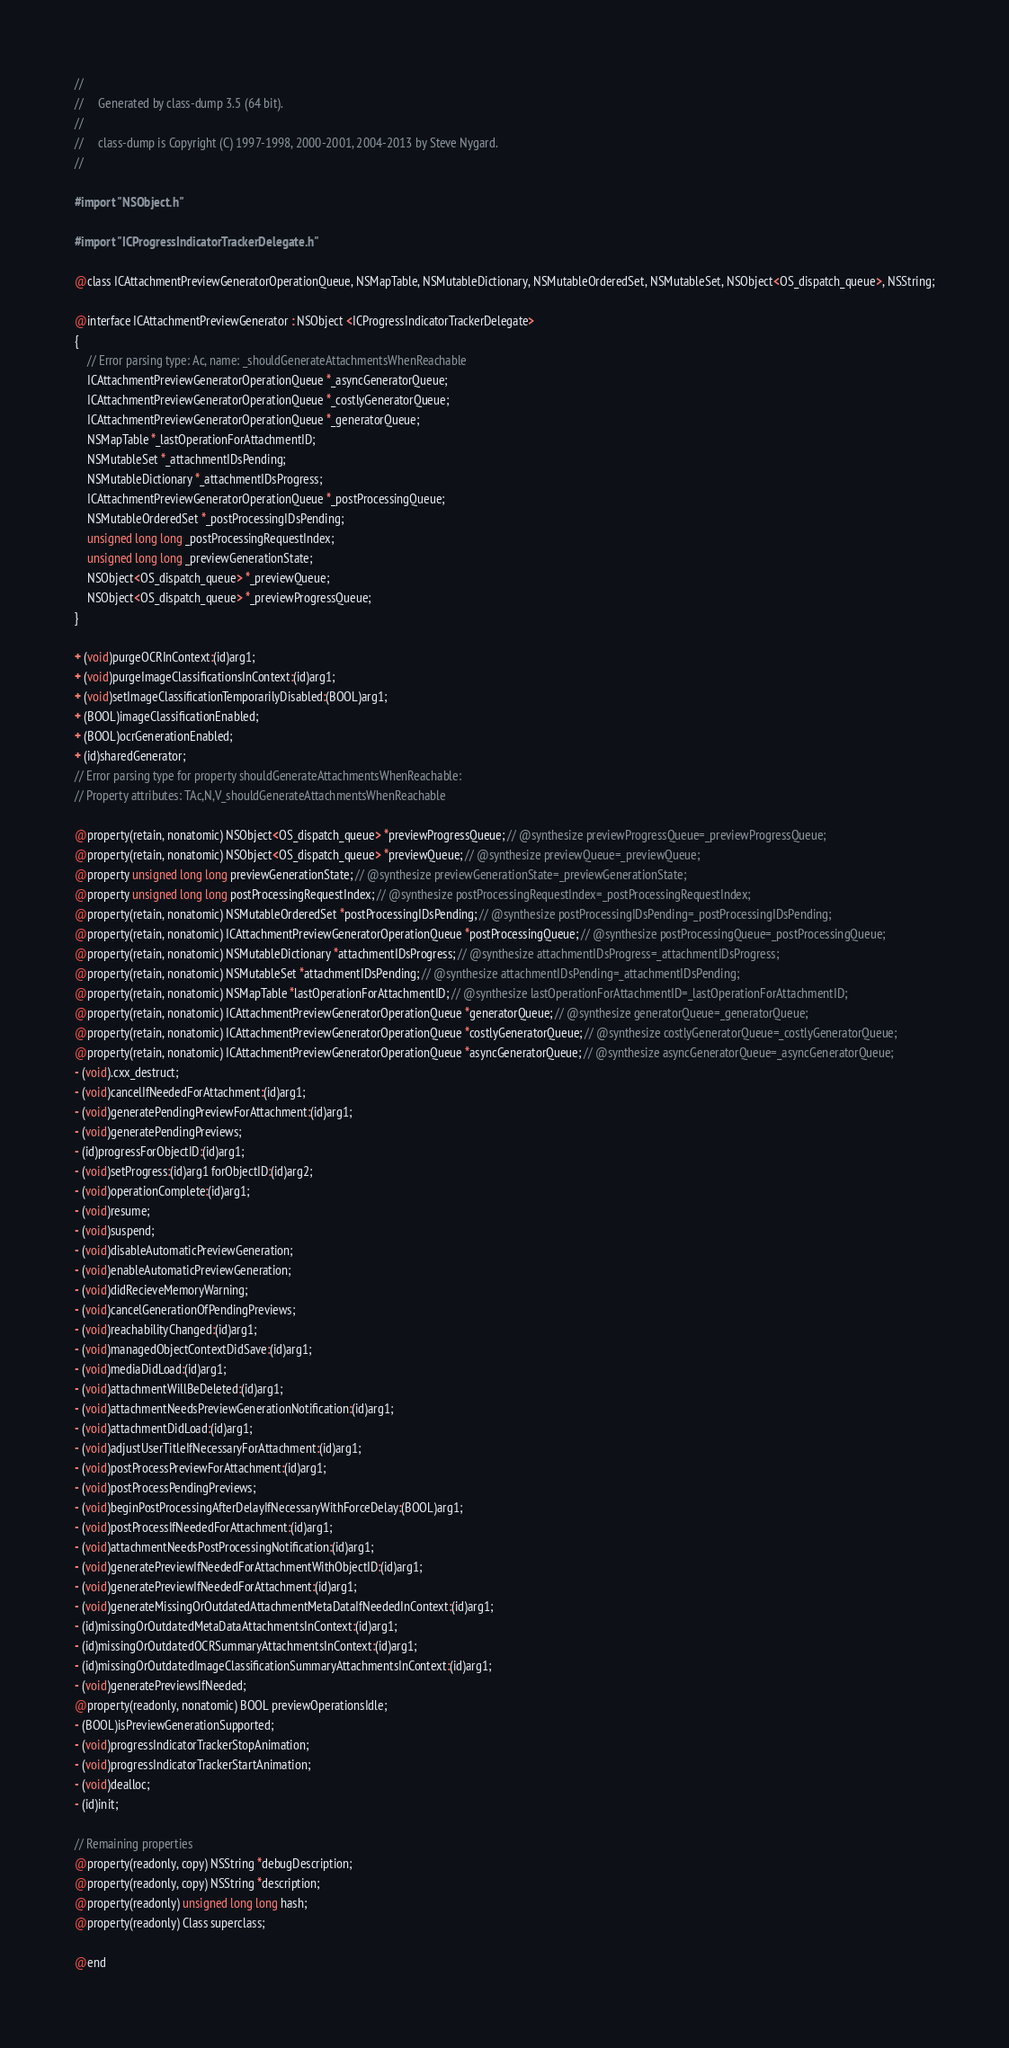Convert code to text. <code><loc_0><loc_0><loc_500><loc_500><_C_>//
//     Generated by class-dump 3.5 (64 bit).
//
//     class-dump is Copyright (C) 1997-1998, 2000-2001, 2004-2013 by Steve Nygard.
//

#import "NSObject.h"

#import "ICProgressIndicatorTrackerDelegate.h"

@class ICAttachmentPreviewGeneratorOperationQueue, NSMapTable, NSMutableDictionary, NSMutableOrderedSet, NSMutableSet, NSObject<OS_dispatch_queue>, NSString;

@interface ICAttachmentPreviewGenerator : NSObject <ICProgressIndicatorTrackerDelegate>
{
    // Error parsing type: Ac, name: _shouldGenerateAttachmentsWhenReachable
    ICAttachmentPreviewGeneratorOperationQueue *_asyncGeneratorQueue;
    ICAttachmentPreviewGeneratorOperationQueue *_costlyGeneratorQueue;
    ICAttachmentPreviewGeneratorOperationQueue *_generatorQueue;
    NSMapTable *_lastOperationForAttachmentID;
    NSMutableSet *_attachmentIDsPending;
    NSMutableDictionary *_attachmentIDsProgress;
    ICAttachmentPreviewGeneratorOperationQueue *_postProcessingQueue;
    NSMutableOrderedSet *_postProcessingIDsPending;
    unsigned long long _postProcessingRequestIndex;
    unsigned long long _previewGenerationState;
    NSObject<OS_dispatch_queue> *_previewQueue;
    NSObject<OS_dispatch_queue> *_previewProgressQueue;
}

+ (void)purgeOCRInContext:(id)arg1;
+ (void)purgeImageClassificationsInContext:(id)arg1;
+ (void)setImageClassificationTemporarilyDisabled:(BOOL)arg1;
+ (BOOL)imageClassificationEnabled;
+ (BOOL)ocrGenerationEnabled;
+ (id)sharedGenerator;
// Error parsing type for property shouldGenerateAttachmentsWhenReachable:
// Property attributes: TAc,N,V_shouldGenerateAttachmentsWhenReachable

@property(retain, nonatomic) NSObject<OS_dispatch_queue> *previewProgressQueue; // @synthesize previewProgressQueue=_previewProgressQueue;
@property(retain, nonatomic) NSObject<OS_dispatch_queue> *previewQueue; // @synthesize previewQueue=_previewQueue;
@property unsigned long long previewGenerationState; // @synthesize previewGenerationState=_previewGenerationState;
@property unsigned long long postProcessingRequestIndex; // @synthesize postProcessingRequestIndex=_postProcessingRequestIndex;
@property(retain, nonatomic) NSMutableOrderedSet *postProcessingIDsPending; // @synthesize postProcessingIDsPending=_postProcessingIDsPending;
@property(retain, nonatomic) ICAttachmentPreviewGeneratorOperationQueue *postProcessingQueue; // @synthesize postProcessingQueue=_postProcessingQueue;
@property(retain, nonatomic) NSMutableDictionary *attachmentIDsProgress; // @synthesize attachmentIDsProgress=_attachmentIDsProgress;
@property(retain, nonatomic) NSMutableSet *attachmentIDsPending; // @synthesize attachmentIDsPending=_attachmentIDsPending;
@property(retain, nonatomic) NSMapTable *lastOperationForAttachmentID; // @synthesize lastOperationForAttachmentID=_lastOperationForAttachmentID;
@property(retain, nonatomic) ICAttachmentPreviewGeneratorOperationQueue *generatorQueue; // @synthesize generatorQueue=_generatorQueue;
@property(retain, nonatomic) ICAttachmentPreviewGeneratorOperationQueue *costlyGeneratorQueue; // @synthesize costlyGeneratorQueue=_costlyGeneratorQueue;
@property(retain, nonatomic) ICAttachmentPreviewGeneratorOperationQueue *asyncGeneratorQueue; // @synthesize asyncGeneratorQueue=_asyncGeneratorQueue;
- (void).cxx_destruct;
- (void)cancelIfNeededForAttachment:(id)arg1;
- (void)generatePendingPreviewForAttachment:(id)arg1;
- (void)generatePendingPreviews;
- (id)progressForObjectID:(id)arg1;
- (void)setProgress:(id)arg1 forObjectID:(id)arg2;
- (void)operationComplete:(id)arg1;
- (void)resume;
- (void)suspend;
- (void)disableAutomaticPreviewGeneration;
- (void)enableAutomaticPreviewGeneration;
- (void)didRecieveMemoryWarning;
- (void)cancelGenerationOfPendingPreviews;
- (void)reachabilityChanged:(id)arg1;
- (void)managedObjectContextDidSave:(id)arg1;
- (void)mediaDidLoad:(id)arg1;
- (void)attachmentWillBeDeleted:(id)arg1;
- (void)attachmentNeedsPreviewGenerationNotification:(id)arg1;
- (void)attachmentDidLoad:(id)arg1;
- (void)adjustUserTitleIfNecessaryForAttachment:(id)arg1;
- (void)postProcessPreviewForAttachment:(id)arg1;
- (void)postProcessPendingPreviews;
- (void)beginPostProcessingAfterDelayIfNecessaryWithForceDelay:(BOOL)arg1;
- (void)postProcessIfNeededForAttachment:(id)arg1;
- (void)attachmentNeedsPostProcessingNotification:(id)arg1;
- (void)generatePreviewIfNeededForAttachmentWithObjectID:(id)arg1;
- (void)generatePreviewIfNeededForAttachment:(id)arg1;
- (void)generateMissingOrOutdatedAttachmentMetaDataIfNeededInContext:(id)arg1;
- (id)missingOrOutdatedMetaDataAttachmentsInContext:(id)arg1;
- (id)missingOrOutdatedOCRSummaryAttachmentsInContext:(id)arg1;
- (id)missingOrOutdatedImageClassificationSummaryAttachmentsInContext:(id)arg1;
- (void)generatePreviewsIfNeeded;
@property(readonly, nonatomic) BOOL previewOperationsIdle;
- (BOOL)isPreviewGenerationSupported;
- (void)progressIndicatorTrackerStopAnimation;
- (void)progressIndicatorTrackerStartAnimation;
- (void)dealloc;
- (id)init;

// Remaining properties
@property(readonly, copy) NSString *debugDescription;
@property(readonly, copy) NSString *description;
@property(readonly) unsigned long long hash;
@property(readonly) Class superclass;

@end

</code> 